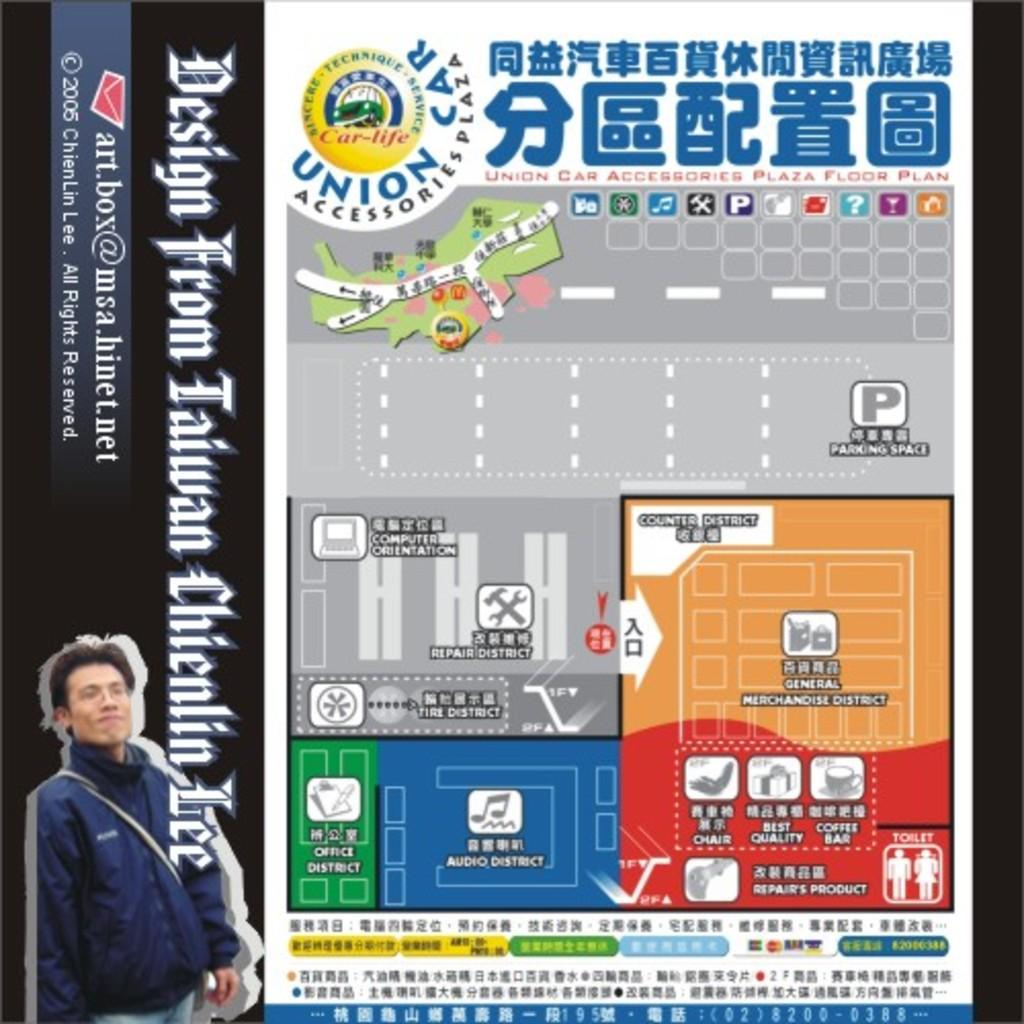<image>
Write a terse but informative summary of the picture. A map of a Union Car Accessories plaza showing where different rooms are located. 